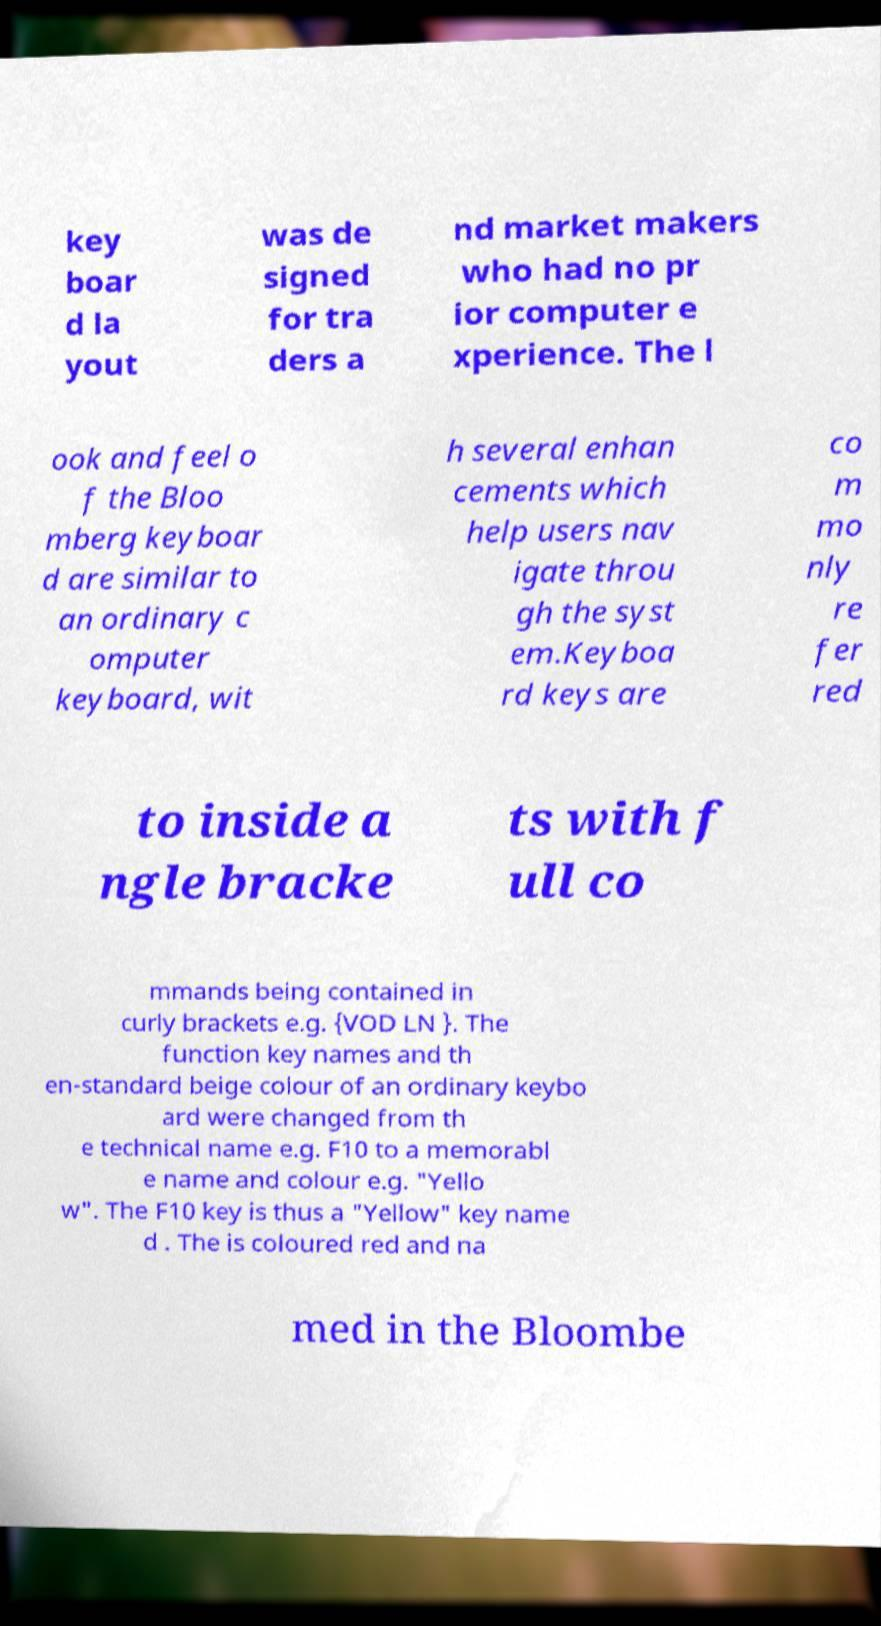Can you accurately transcribe the text from the provided image for me? key boar d la yout was de signed for tra ders a nd market makers who had no pr ior computer e xperience. The l ook and feel o f the Bloo mberg keyboar d are similar to an ordinary c omputer keyboard, wit h several enhan cements which help users nav igate throu gh the syst em.Keyboa rd keys are co m mo nly re fer red to inside a ngle bracke ts with f ull co mmands being contained in curly brackets e.g. {VOD LN }. The function key names and th en-standard beige colour of an ordinary keybo ard were changed from th e technical name e.g. F10 to a memorabl e name and colour e.g. "Yello w". The F10 key is thus a "Yellow" key name d . The is coloured red and na med in the Bloombe 